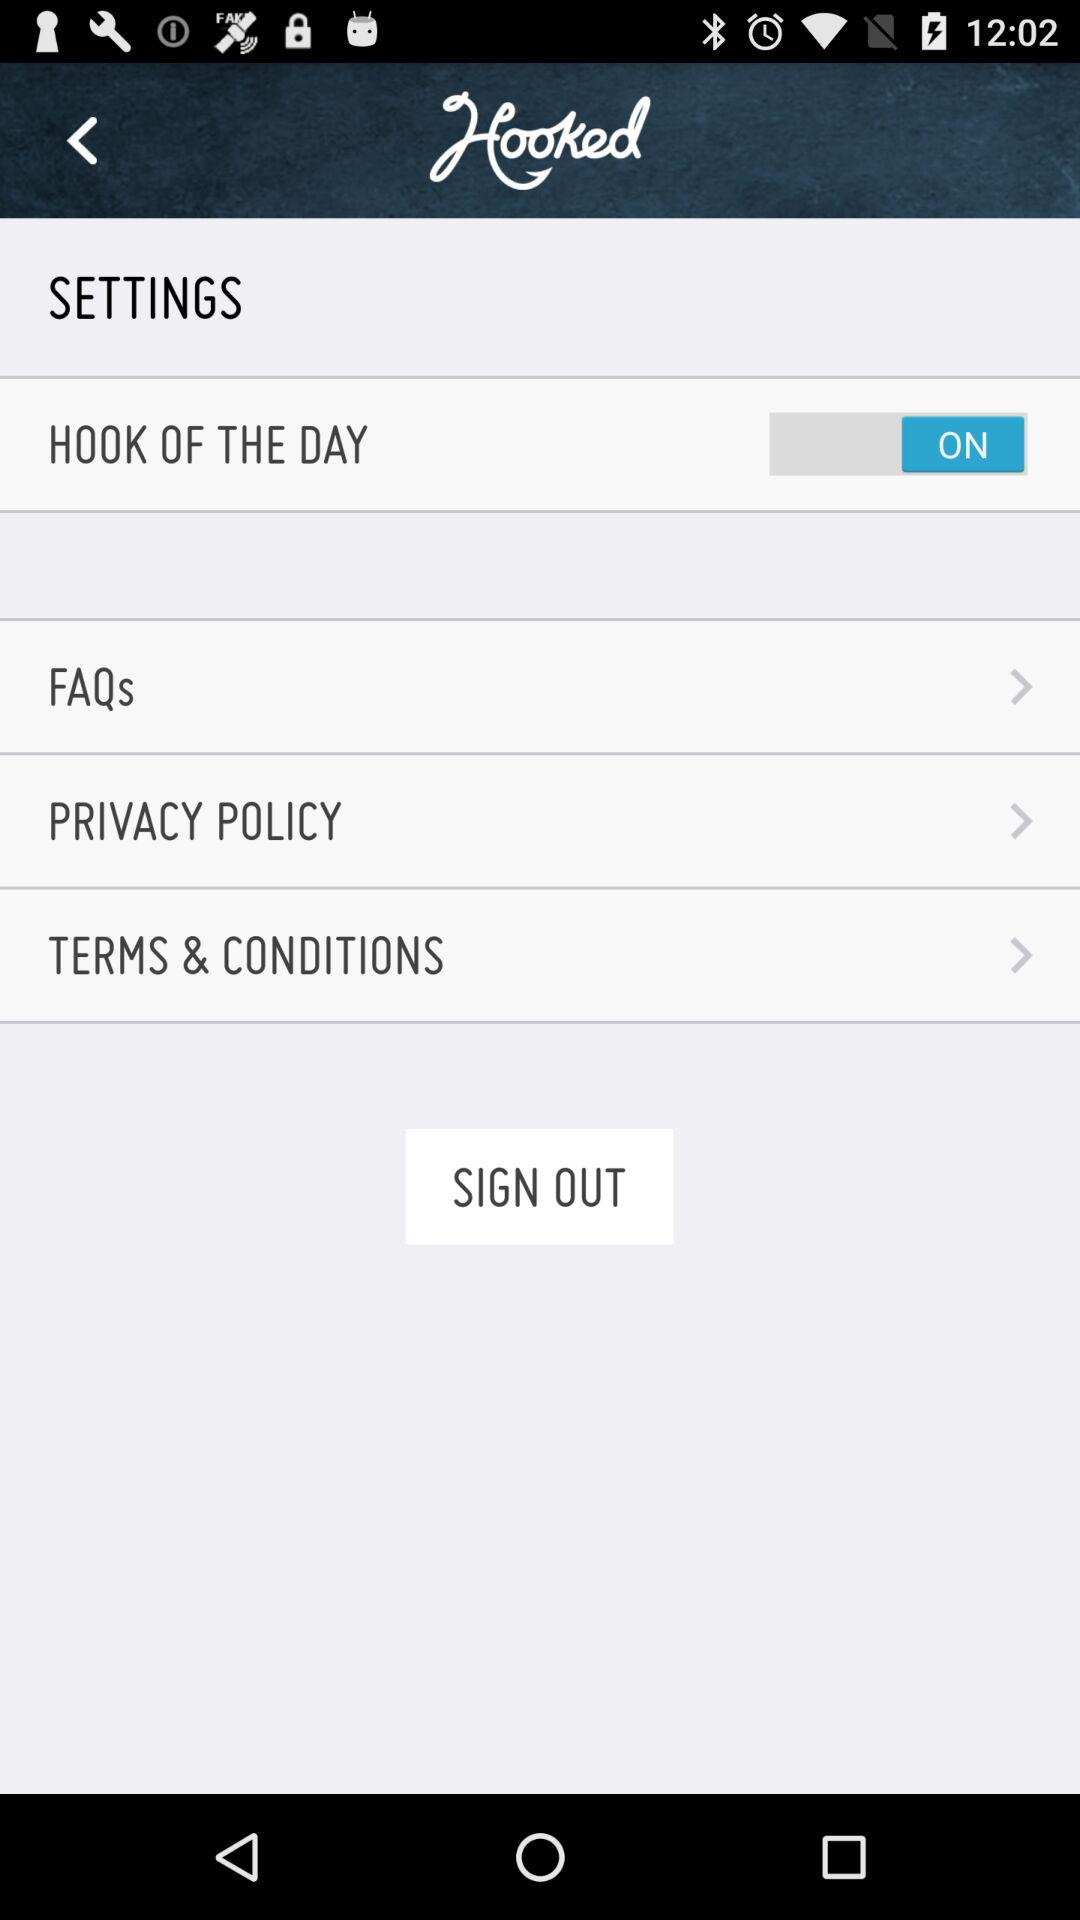What is the status of the "HOOK OF THE DAY"? The status is "on". 